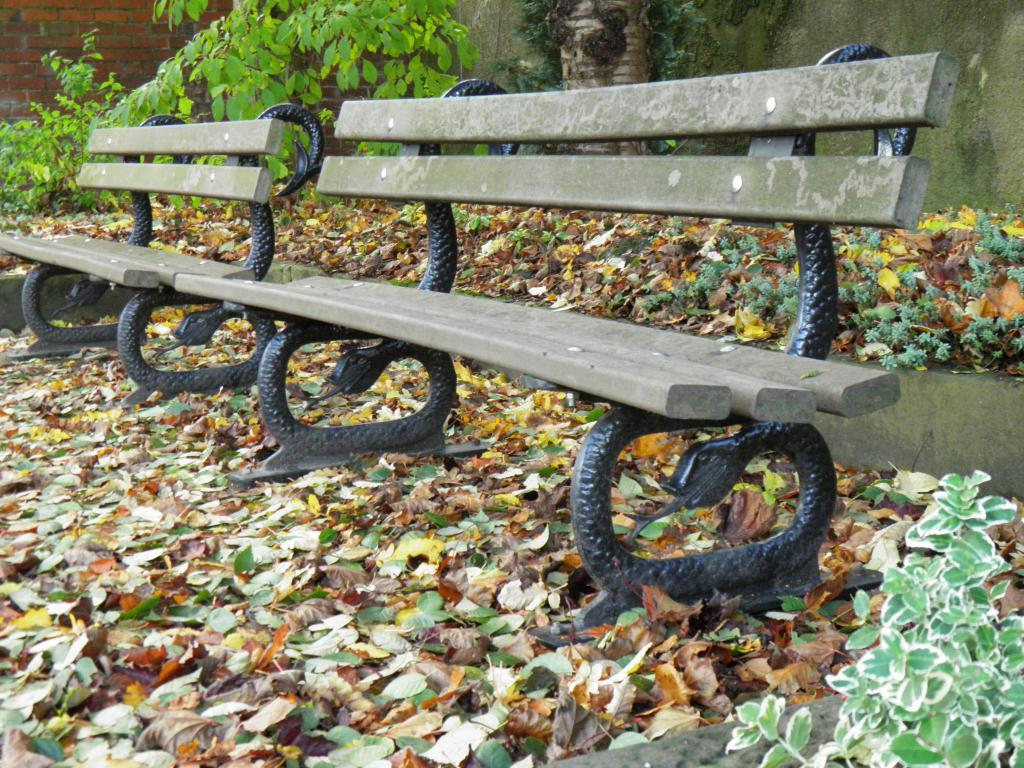What type: What type of seating is available on the ground in the image? There are benches on the ground in the image. What can be seen in the background of the image? There is a wall and plants visible in the background of the image. Reasoning: Let' Let's think step by step in order to produce the conversation. We start by identifying the main subject in the image, which is the benches on the ground. Then, we expand the conversation to include other elements visible in the background, such as the wall and plants. Each question is designed to elicit a specific detail about the image that is known from the provided facts. Absurd Question/Answer: What type of marble is used for the secretary's desk in the image? There is no secretary or desk present in the image; it only features benches, a wall, and plants. 